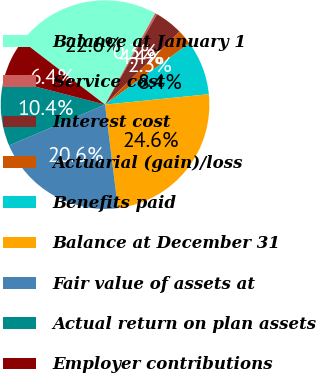<chart> <loc_0><loc_0><loc_500><loc_500><pie_chart><fcel>Balance at January 1<fcel>Service cost<fcel>Interest cost<fcel>Actuarial (gain)/loss<fcel>Benefits paid<fcel>Balance at December 31<fcel>Fair value of assets at<fcel>Actual return on plan assets<fcel>Employer contributions<nl><fcel>22.59%<fcel>0.31%<fcel>4.36%<fcel>2.33%<fcel>8.41%<fcel>24.62%<fcel>20.57%<fcel>10.44%<fcel>6.38%<nl></chart> 